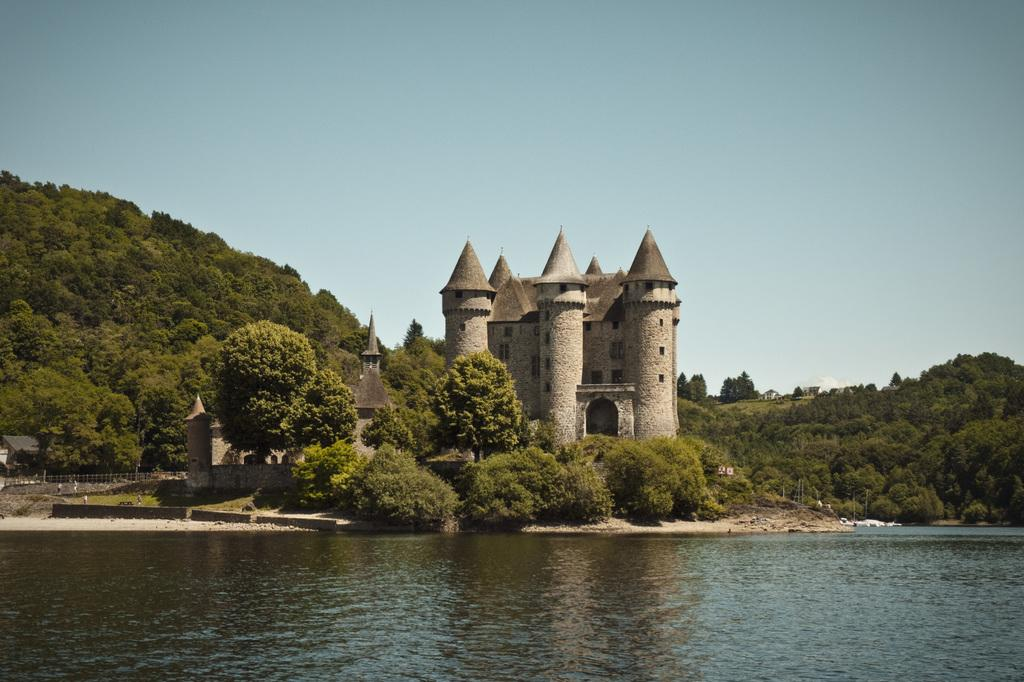What type of structures can be seen in the image? There are buildings in the image. What natural elements are present in the image? There are trees and plants in the image. What can be seen in the water in the image? The image shows water with some objects in it. What type of barrier is visible in the image? There is a fence in the image. What parts of the environment are visible in the image? The sky and the ground are visible in the image. What type of stage can be seen in the image? There is no stage present in the image. How does the lock work in the image? There is no lock present in the image. 